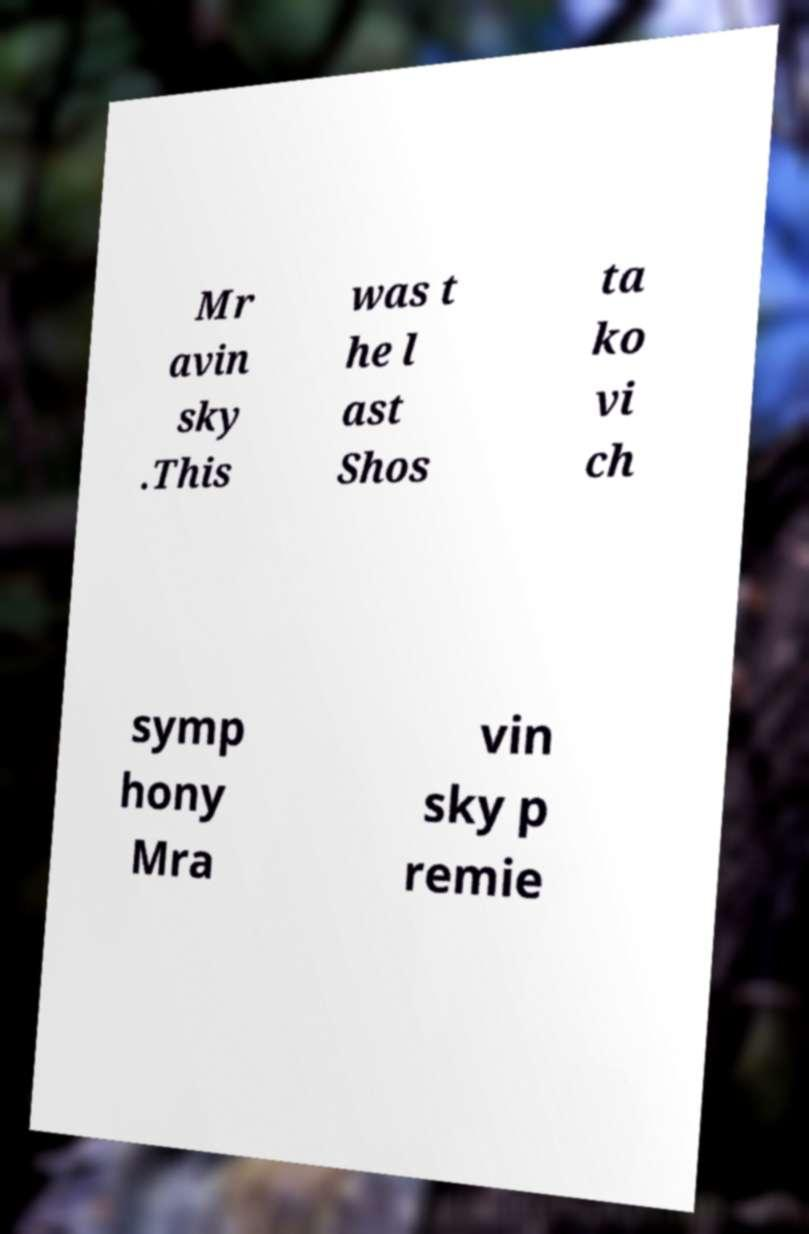For documentation purposes, I need the text within this image transcribed. Could you provide that? Mr avin sky .This was t he l ast Shos ta ko vi ch symp hony Mra vin sky p remie 